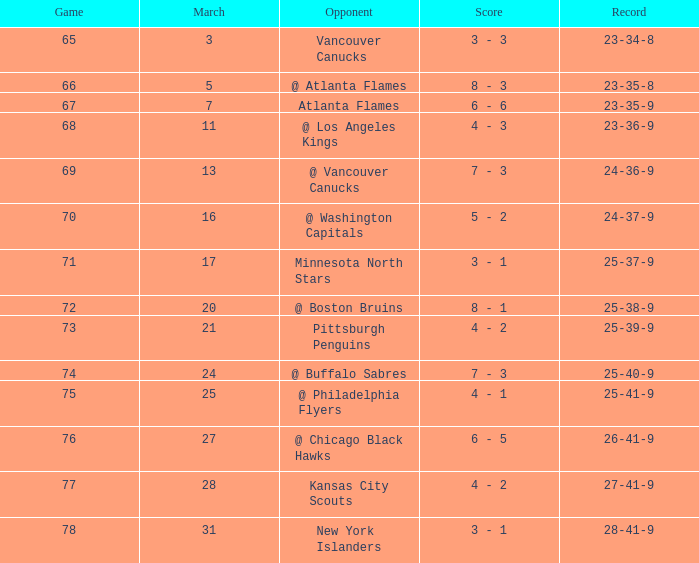What is the game associated with a score of 4 - 2, and a record of 25-39-9? 73.0. 